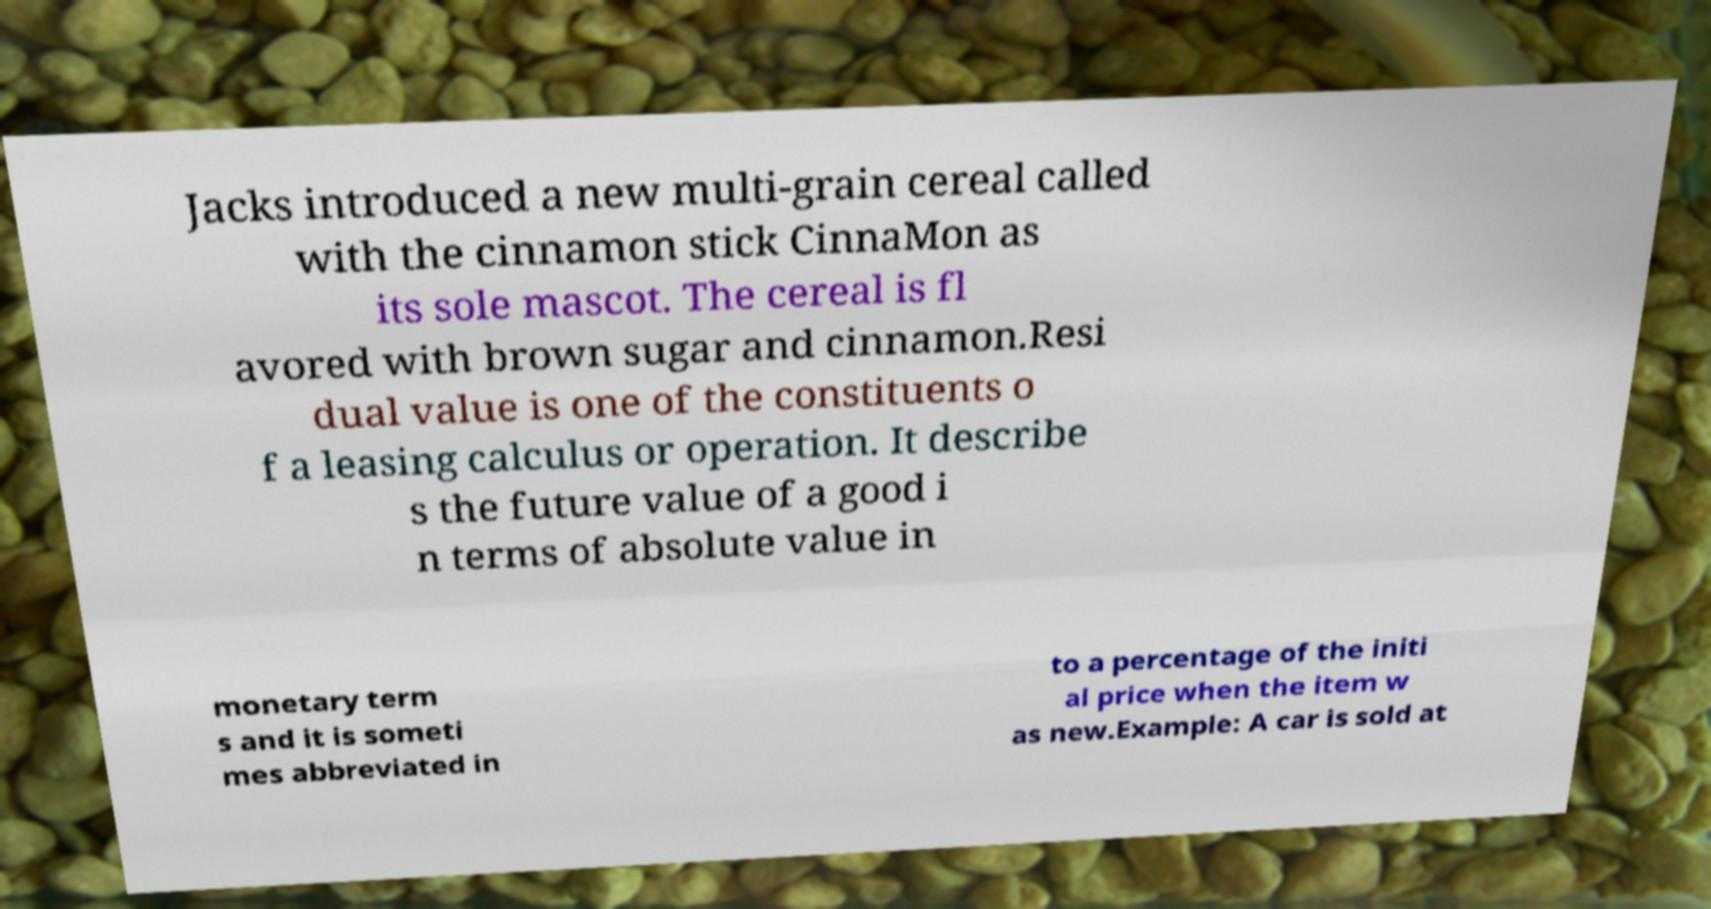I need the written content from this picture converted into text. Can you do that? Jacks introduced a new multi-grain cereal called with the cinnamon stick CinnaMon as its sole mascot. The cereal is fl avored with brown sugar and cinnamon.Resi dual value is one of the constituents o f a leasing calculus or operation. It describe s the future value of a good i n terms of absolute value in monetary term s and it is someti mes abbreviated in to a percentage of the initi al price when the item w as new.Example: A car is sold at 